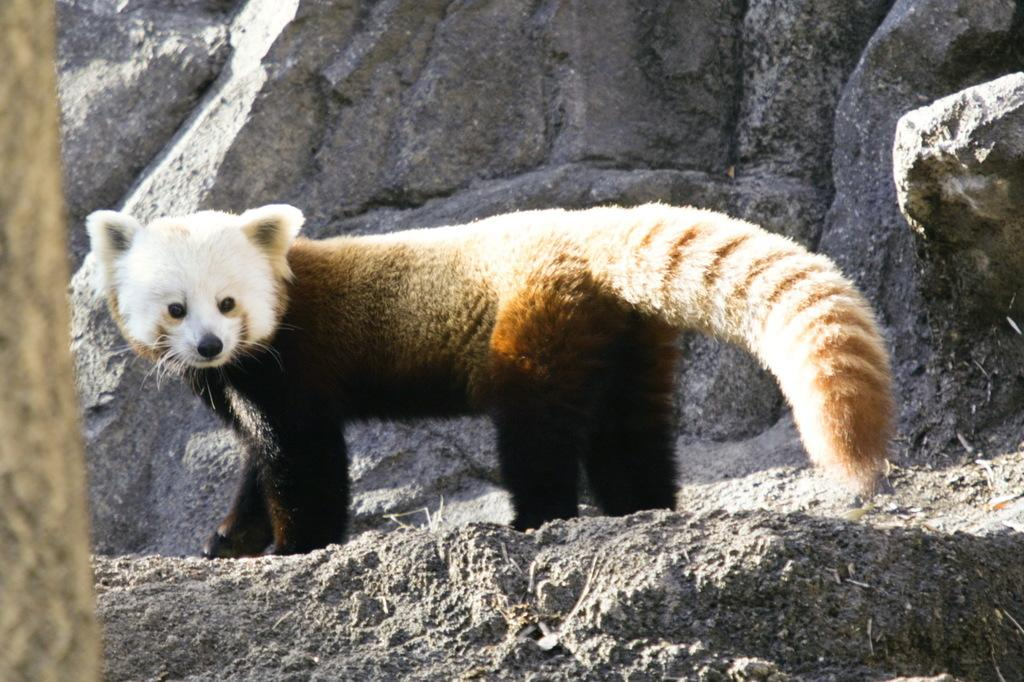What type of creature is present in the image? There is an animal in the image. Can you describe the animal's position or stance? The animal is standing on a rock. What is the range of the worm in the image? There is no worm present in the image, so it is not possible to determine its range. 